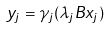Convert formula to latex. <formula><loc_0><loc_0><loc_500><loc_500>y _ { j } = \gamma _ { j } ( \lambda _ { j } B x _ { j } )</formula> 